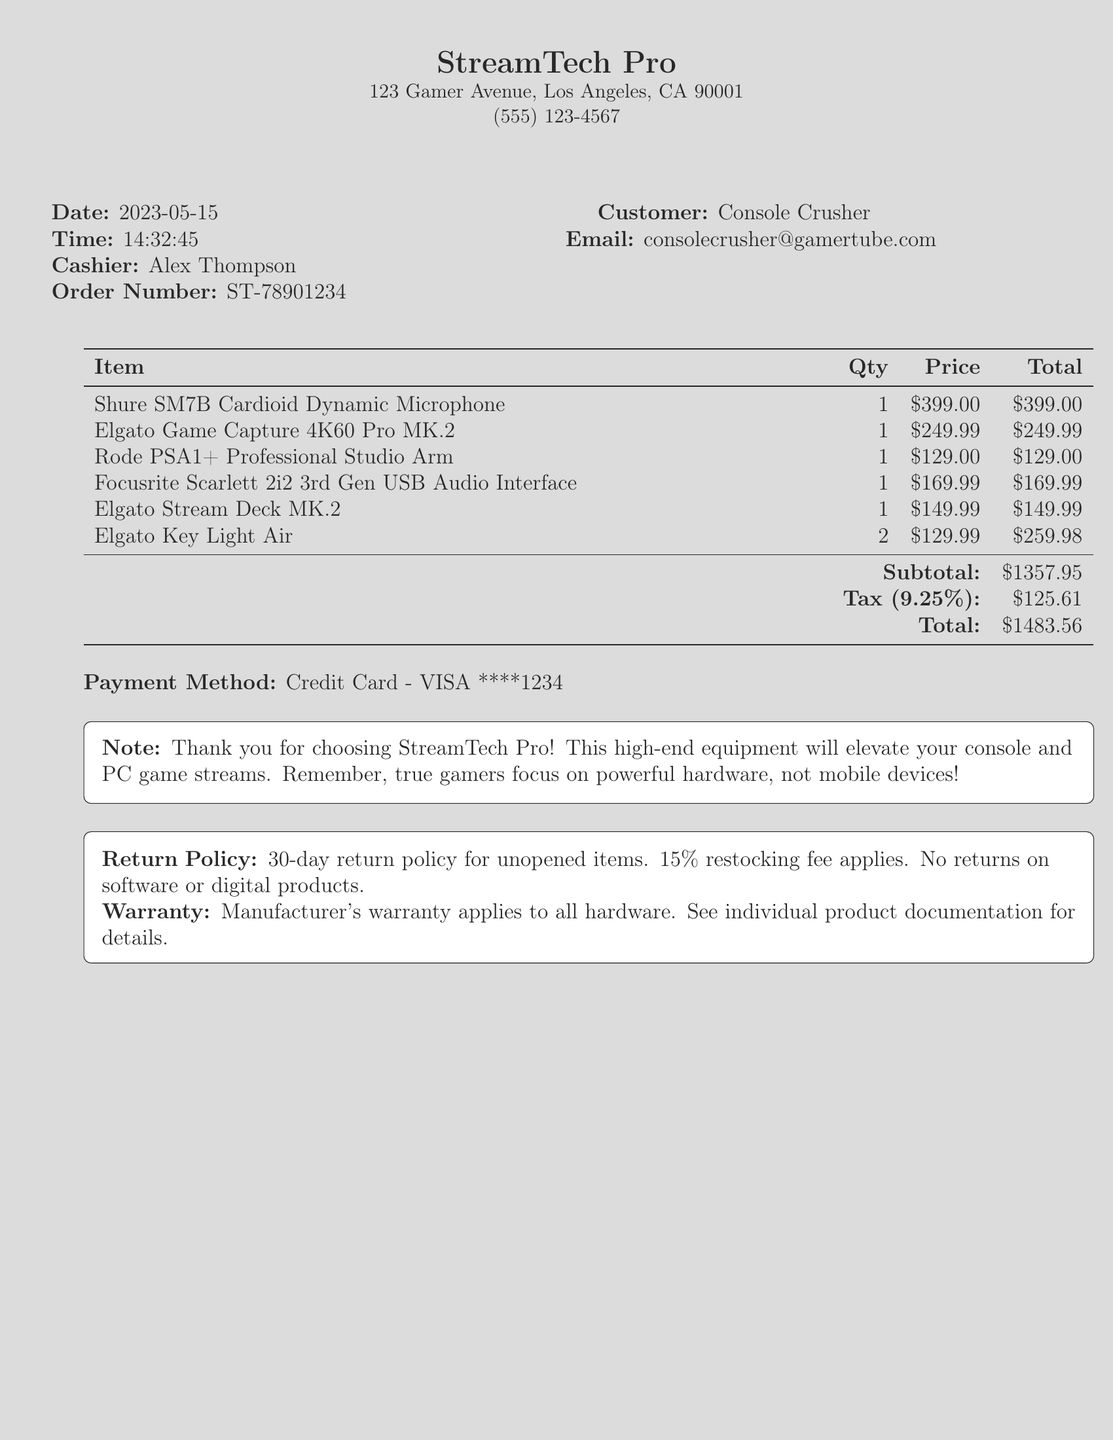What is the store name? The store name is the first piece of information listed in the document.
Answer: StreamTech Pro What is the date of purchase? The date of purchase is clearly stated in the document under the date heading.
Answer: 2023-05-15 Who was the cashier? The cashier's name is mentioned right after the date and time information.
Answer: Alex Thompson What is the total amount paid? The total amount is calculated and listed at the bottom of the itemized list.
Answer: $1483.56 How many Elgato Key Light Air units were purchased? The quantity of Elgato Key Light Air is specified directly next to its name in the item list.
Answer: 2 What is the return policy duration for unopened items? The return policy duration is specifically mentioned in the document in its return policy section.
Answer: 30-day What payment method was used? The payment method is provided toward the end of the document along with the relevant details.
Answer: Credit Card - VISA ****1234 Which microphone was purchased? The name of the microphone is listed in the itemized list of purchased items.
Answer: Shure SM7B Cardioid Dynamic Microphone What note is included in the receipt? The note section outlines a custom message thanking the customer and emphasizing the focus on gaming hardware.
Answer: Thank you for choosing StreamTech Pro! This high-end equipment will elevate your console and PC game streams. Remember, true gamers focus on powerful hardware, not mobile devices! 